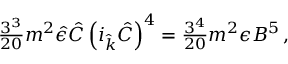Convert formula to latex. <formula><loc_0><loc_0><loc_500><loc_500>{ \frac { 3 ^ { 3 } } { 2 0 } } m ^ { 2 } \hat { \epsilon } \hat { C } \left ( i _ { \hat { k } } \hat { C } \right ) ^ { 4 } = { \frac { 3 ^ { 4 } } { 2 0 } } m ^ { 2 } \epsilon B ^ { 5 } \, ,</formula> 